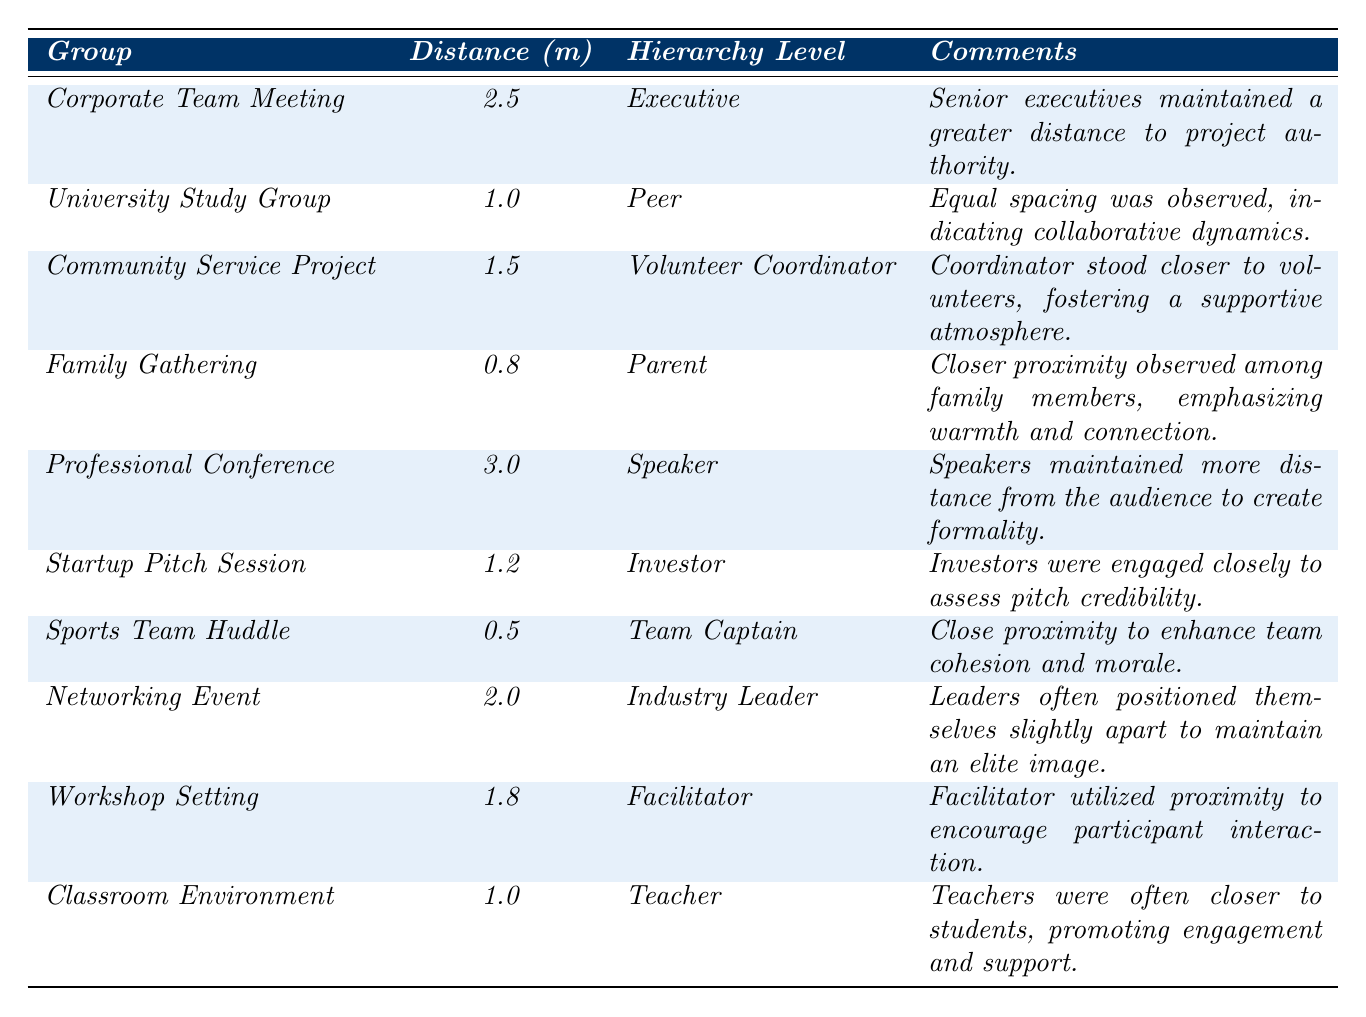What is the spatial distance in the Corporate Team Meeting? The table lists the spatial distance for the Corporate Team Meeting as 2.5 meters.
Answer: 2.5 meters Which group had the closest proximity, and what was the distance? The Sports Team Huddle had the closest proximity with a distance of 0.5 meters.
Answer: Sports Team Huddle, 0.5 meters What hierarchy level is associated with the Family Gathering? The hierarchy level associated with the Family Gathering is "Parent."
Answer: Parent What is the average spatial distance for the groups labeled as "Peer"? There are two groups labeled as "Peer": University Study Group (1.0 meters) and Classroom Environment (1.0 meters), so the average is (1.0 + 1.0) / 2 = 1.0 meters.
Answer: 1.0 meters How many groups maintained a distance greater than 2 meters? The groups that maintained a distance greater than 2 meters are Corporate Team Meeting (2.5 meters), Professional Conference (3.0 meters), and Networking Event (2.0 meters), totaling 3 groups.
Answer: 3 groups Did the Volunteer Coordinator maintain a closer distance to volunteers than the Teacher did to students? The Volunteer Coordinator stood at 1.5 meters while the Teacher was at 1.0 meters. Thus, the Teacher maintained a closer distance than the Volunteer Coordinator.
Answer: No What can be inferred about the relationship between hierarchy level and spatial distance in this dataset? Higher perceived hierarchy levels tend to associate with greater spatial distances (e.g., Speaker and Executive). In contrast, lower hierarchy levels (like Parent and Team Captain) are associated with closer distances.
Answer: Higher hierarchy levels correlate with greater spatial distances 